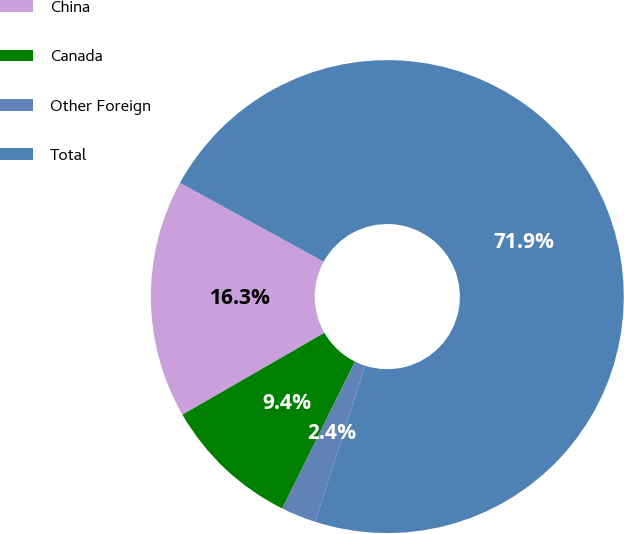Convert chart. <chart><loc_0><loc_0><loc_500><loc_500><pie_chart><fcel>China<fcel>Canada<fcel>Other Foreign<fcel>Total<nl><fcel>16.31%<fcel>9.35%<fcel>2.39%<fcel>71.95%<nl></chart> 